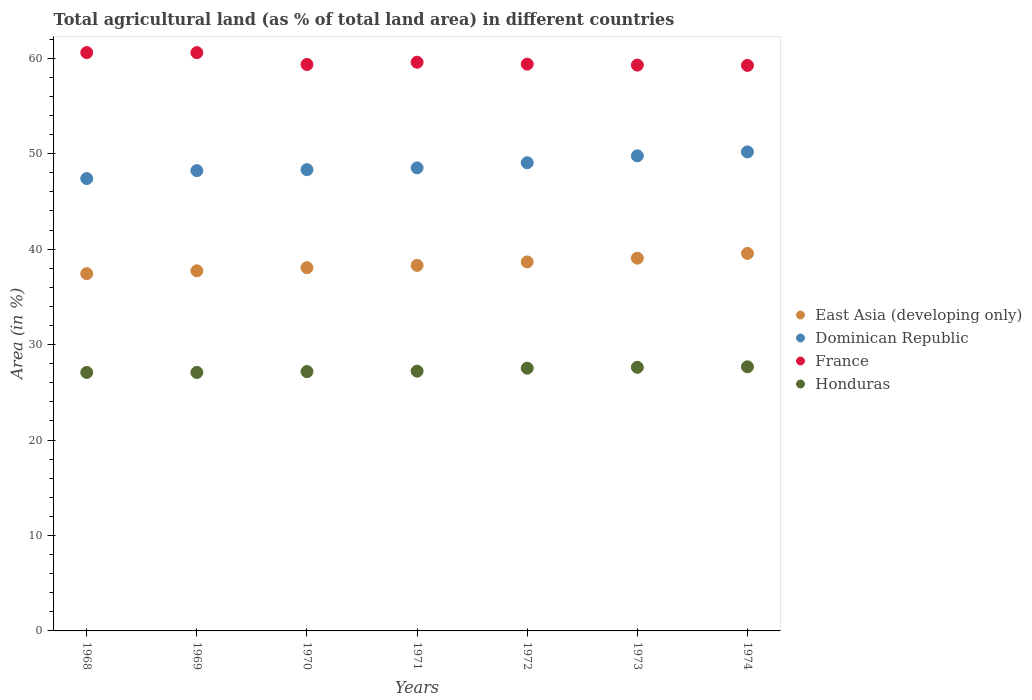How many different coloured dotlines are there?
Keep it short and to the point. 4. What is the percentage of agricultural land in East Asia (developing only) in 1970?
Your answer should be very brief. 38.05. Across all years, what is the maximum percentage of agricultural land in France?
Keep it short and to the point. 60.59. Across all years, what is the minimum percentage of agricultural land in France?
Provide a short and direct response. 59.25. In which year was the percentage of agricultural land in Honduras maximum?
Your response must be concise. 1974. In which year was the percentage of agricultural land in Dominican Republic minimum?
Keep it short and to the point. 1968. What is the total percentage of agricultural land in East Asia (developing only) in the graph?
Keep it short and to the point. 268.76. What is the difference between the percentage of agricultural land in East Asia (developing only) in 1970 and that in 1971?
Offer a terse response. -0.24. What is the difference between the percentage of agricultural land in France in 1970 and the percentage of agricultural land in Honduras in 1974?
Offer a very short reply. 31.67. What is the average percentage of agricultural land in East Asia (developing only) per year?
Make the answer very short. 38.39. In the year 1970, what is the difference between the percentage of agricultural land in France and percentage of agricultural land in Dominican Republic?
Offer a terse response. 11.02. In how many years, is the percentage of agricultural land in France greater than 6 %?
Keep it short and to the point. 7. What is the ratio of the percentage of agricultural land in France in 1969 to that in 1970?
Make the answer very short. 1.02. What is the difference between the highest and the second highest percentage of agricultural land in France?
Keep it short and to the point. 0.01. What is the difference between the highest and the lowest percentage of agricultural land in France?
Provide a succinct answer. 1.34. Is the percentage of agricultural land in France strictly less than the percentage of agricultural land in Honduras over the years?
Keep it short and to the point. No. How many dotlines are there?
Your answer should be very brief. 4. How many years are there in the graph?
Give a very brief answer. 7. Does the graph contain any zero values?
Make the answer very short. No. Does the graph contain grids?
Your response must be concise. No. Where does the legend appear in the graph?
Offer a very short reply. Center right. How many legend labels are there?
Offer a very short reply. 4. What is the title of the graph?
Offer a very short reply. Total agricultural land (as % of total land area) in different countries. Does "Sint Maarten (Dutch part)" appear as one of the legend labels in the graph?
Give a very brief answer. No. What is the label or title of the X-axis?
Provide a succinct answer. Years. What is the label or title of the Y-axis?
Your answer should be very brief. Area (in %). What is the Area (in %) of East Asia (developing only) in 1968?
Make the answer very short. 37.43. What is the Area (in %) of Dominican Republic in 1968?
Make the answer very short. 47.39. What is the Area (in %) of France in 1968?
Give a very brief answer. 60.59. What is the Area (in %) in Honduras in 1968?
Ensure brevity in your answer.  27.08. What is the Area (in %) in East Asia (developing only) in 1969?
Ensure brevity in your answer.  37.73. What is the Area (in %) in Dominican Republic in 1969?
Give a very brief answer. 48.22. What is the Area (in %) of France in 1969?
Give a very brief answer. 60.58. What is the Area (in %) in Honduras in 1969?
Your response must be concise. 27.08. What is the Area (in %) of East Asia (developing only) in 1970?
Provide a short and direct response. 38.05. What is the Area (in %) in Dominican Republic in 1970?
Your answer should be very brief. 48.32. What is the Area (in %) in France in 1970?
Ensure brevity in your answer.  59.34. What is the Area (in %) in Honduras in 1970?
Your answer should be compact. 27.17. What is the Area (in %) in East Asia (developing only) in 1971?
Offer a very short reply. 38.29. What is the Area (in %) in Dominican Republic in 1971?
Your answer should be compact. 48.51. What is the Area (in %) in France in 1971?
Give a very brief answer. 59.58. What is the Area (in %) of Honduras in 1971?
Your answer should be compact. 27.21. What is the Area (in %) of East Asia (developing only) in 1972?
Provide a short and direct response. 38.66. What is the Area (in %) in Dominican Republic in 1972?
Give a very brief answer. 49.05. What is the Area (in %) of France in 1972?
Keep it short and to the point. 59.38. What is the Area (in %) of Honduras in 1972?
Your response must be concise. 27.53. What is the Area (in %) of East Asia (developing only) in 1973?
Keep it short and to the point. 39.05. What is the Area (in %) in Dominican Republic in 1973?
Provide a succinct answer. 49.77. What is the Area (in %) of France in 1973?
Your answer should be very brief. 59.28. What is the Area (in %) of Honduras in 1973?
Ensure brevity in your answer.  27.62. What is the Area (in %) in East Asia (developing only) in 1974?
Keep it short and to the point. 39.55. What is the Area (in %) in Dominican Republic in 1974?
Keep it short and to the point. 50.19. What is the Area (in %) of France in 1974?
Offer a terse response. 59.25. What is the Area (in %) in Honduras in 1974?
Offer a terse response. 27.67. Across all years, what is the maximum Area (in %) in East Asia (developing only)?
Your answer should be compact. 39.55. Across all years, what is the maximum Area (in %) of Dominican Republic?
Your response must be concise. 50.19. Across all years, what is the maximum Area (in %) in France?
Provide a short and direct response. 60.59. Across all years, what is the maximum Area (in %) in Honduras?
Ensure brevity in your answer.  27.67. Across all years, what is the minimum Area (in %) in East Asia (developing only)?
Your response must be concise. 37.43. Across all years, what is the minimum Area (in %) of Dominican Republic?
Offer a terse response. 47.39. Across all years, what is the minimum Area (in %) of France?
Offer a very short reply. 59.25. Across all years, what is the minimum Area (in %) of Honduras?
Make the answer very short. 27.08. What is the total Area (in %) in East Asia (developing only) in the graph?
Your answer should be very brief. 268.76. What is the total Area (in %) of Dominican Republic in the graph?
Ensure brevity in your answer.  341.45. What is the total Area (in %) of France in the graph?
Offer a very short reply. 418.01. What is the total Area (in %) of Honduras in the graph?
Provide a short and direct response. 191.36. What is the difference between the Area (in %) in East Asia (developing only) in 1968 and that in 1969?
Offer a very short reply. -0.3. What is the difference between the Area (in %) in Dominican Republic in 1968 and that in 1969?
Keep it short and to the point. -0.83. What is the difference between the Area (in %) of France in 1968 and that in 1969?
Offer a very short reply. 0.01. What is the difference between the Area (in %) in Honduras in 1968 and that in 1969?
Ensure brevity in your answer.  0. What is the difference between the Area (in %) of East Asia (developing only) in 1968 and that in 1970?
Offer a very short reply. -0.62. What is the difference between the Area (in %) of Dominican Republic in 1968 and that in 1970?
Offer a very short reply. -0.93. What is the difference between the Area (in %) in France in 1968 and that in 1970?
Give a very brief answer. 1.25. What is the difference between the Area (in %) in Honduras in 1968 and that in 1970?
Your answer should be compact. -0.09. What is the difference between the Area (in %) of East Asia (developing only) in 1968 and that in 1971?
Provide a succinct answer. -0.86. What is the difference between the Area (in %) of Dominican Republic in 1968 and that in 1971?
Ensure brevity in your answer.  -1.12. What is the difference between the Area (in %) in France in 1968 and that in 1971?
Provide a short and direct response. 1.01. What is the difference between the Area (in %) in Honduras in 1968 and that in 1971?
Keep it short and to the point. -0.13. What is the difference between the Area (in %) in East Asia (developing only) in 1968 and that in 1972?
Ensure brevity in your answer.  -1.23. What is the difference between the Area (in %) in Dominican Republic in 1968 and that in 1972?
Make the answer very short. -1.66. What is the difference between the Area (in %) in France in 1968 and that in 1972?
Offer a terse response. 1.21. What is the difference between the Area (in %) of Honduras in 1968 and that in 1972?
Your response must be concise. -0.45. What is the difference between the Area (in %) in East Asia (developing only) in 1968 and that in 1973?
Provide a short and direct response. -1.62. What is the difference between the Area (in %) in Dominican Republic in 1968 and that in 1973?
Make the answer very short. -2.38. What is the difference between the Area (in %) in France in 1968 and that in 1973?
Your answer should be very brief. 1.31. What is the difference between the Area (in %) of Honduras in 1968 and that in 1973?
Keep it short and to the point. -0.54. What is the difference between the Area (in %) of East Asia (developing only) in 1968 and that in 1974?
Provide a short and direct response. -2.12. What is the difference between the Area (in %) in Dominican Republic in 1968 and that in 1974?
Your answer should be very brief. -2.79. What is the difference between the Area (in %) in France in 1968 and that in 1974?
Provide a succinct answer. 1.34. What is the difference between the Area (in %) in Honduras in 1968 and that in 1974?
Provide a succinct answer. -0.59. What is the difference between the Area (in %) of East Asia (developing only) in 1969 and that in 1970?
Keep it short and to the point. -0.32. What is the difference between the Area (in %) in Dominican Republic in 1969 and that in 1970?
Your answer should be compact. -0.1. What is the difference between the Area (in %) in France in 1969 and that in 1970?
Offer a very short reply. 1.24. What is the difference between the Area (in %) in Honduras in 1969 and that in 1970?
Provide a short and direct response. -0.09. What is the difference between the Area (in %) of East Asia (developing only) in 1969 and that in 1971?
Provide a succinct answer. -0.57. What is the difference between the Area (in %) of Dominican Republic in 1969 and that in 1971?
Your answer should be very brief. -0.29. What is the difference between the Area (in %) in Honduras in 1969 and that in 1971?
Your answer should be compact. -0.13. What is the difference between the Area (in %) in East Asia (developing only) in 1969 and that in 1972?
Offer a very short reply. -0.93. What is the difference between the Area (in %) in Dominican Republic in 1969 and that in 1972?
Your answer should be very brief. -0.83. What is the difference between the Area (in %) of France in 1969 and that in 1972?
Keep it short and to the point. 1.2. What is the difference between the Area (in %) of Honduras in 1969 and that in 1972?
Your response must be concise. -0.45. What is the difference between the Area (in %) in East Asia (developing only) in 1969 and that in 1973?
Your answer should be compact. -1.33. What is the difference between the Area (in %) of Dominican Republic in 1969 and that in 1973?
Provide a short and direct response. -1.55. What is the difference between the Area (in %) in France in 1969 and that in 1973?
Provide a short and direct response. 1.3. What is the difference between the Area (in %) in Honduras in 1969 and that in 1973?
Provide a short and direct response. -0.54. What is the difference between the Area (in %) of East Asia (developing only) in 1969 and that in 1974?
Give a very brief answer. -1.82. What is the difference between the Area (in %) in Dominican Republic in 1969 and that in 1974?
Ensure brevity in your answer.  -1.97. What is the difference between the Area (in %) in France in 1969 and that in 1974?
Your answer should be very brief. 1.33. What is the difference between the Area (in %) in Honduras in 1969 and that in 1974?
Your answer should be very brief. -0.59. What is the difference between the Area (in %) of East Asia (developing only) in 1970 and that in 1971?
Make the answer very short. -0.24. What is the difference between the Area (in %) of Dominican Republic in 1970 and that in 1971?
Make the answer very short. -0.19. What is the difference between the Area (in %) in France in 1970 and that in 1971?
Ensure brevity in your answer.  -0.23. What is the difference between the Area (in %) in Honduras in 1970 and that in 1971?
Offer a terse response. -0.04. What is the difference between the Area (in %) of East Asia (developing only) in 1970 and that in 1972?
Your response must be concise. -0.61. What is the difference between the Area (in %) of Dominican Republic in 1970 and that in 1972?
Provide a short and direct response. -0.72. What is the difference between the Area (in %) in France in 1970 and that in 1972?
Give a very brief answer. -0.04. What is the difference between the Area (in %) in Honduras in 1970 and that in 1972?
Provide a short and direct response. -0.36. What is the difference between the Area (in %) of East Asia (developing only) in 1970 and that in 1973?
Provide a succinct answer. -1. What is the difference between the Area (in %) in Dominican Republic in 1970 and that in 1973?
Offer a very short reply. -1.45. What is the difference between the Area (in %) of France in 1970 and that in 1973?
Offer a very short reply. 0.06. What is the difference between the Area (in %) in Honduras in 1970 and that in 1973?
Provide a short and direct response. -0.45. What is the difference between the Area (in %) in East Asia (developing only) in 1970 and that in 1974?
Offer a very short reply. -1.5. What is the difference between the Area (in %) of Dominican Republic in 1970 and that in 1974?
Offer a terse response. -1.86. What is the difference between the Area (in %) in France in 1970 and that in 1974?
Provide a succinct answer. 0.1. What is the difference between the Area (in %) of Honduras in 1970 and that in 1974?
Provide a short and direct response. -0.5. What is the difference between the Area (in %) of East Asia (developing only) in 1971 and that in 1972?
Your response must be concise. -0.36. What is the difference between the Area (in %) of Dominican Republic in 1971 and that in 1972?
Your response must be concise. -0.54. What is the difference between the Area (in %) of France in 1971 and that in 1972?
Your answer should be very brief. 0.2. What is the difference between the Area (in %) of Honduras in 1971 and that in 1972?
Ensure brevity in your answer.  -0.31. What is the difference between the Area (in %) in East Asia (developing only) in 1971 and that in 1973?
Give a very brief answer. -0.76. What is the difference between the Area (in %) of Dominican Republic in 1971 and that in 1973?
Ensure brevity in your answer.  -1.26. What is the difference between the Area (in %) of France in 1971 and that in 1973?
Provide a short and direct response. 0.3. What is the difference between the Area (in %) of Honduras in 1971 and that in 1973?
Your answer should be very brief. -0.4. What is the difference between the Area (in %) in East Asia (developing only) in 1971 and that in 1974?
Ensure brevity in your answer.  -1.25. What is the difference between the Area (in %) of Dominican Republic in 1971 and that in 1974?
Keep it short and to the point. -1.68. What is the difference between the Area (in %) in France in 1971 and that in 1974?
Offer a very short reply. 0.33. What is the difference between the Area (in %) in Honduras in 1971 and that in 1974?
Give a very brief answer. -0.46. What is the difference between the Area (in %) of East Asia (developing only) in 1972 and that in 1973?
Make the answer very short. -0.4. What is the difference between the Area (in %) in Dominican Republic in 1972 and that in 1973?
Keep it short and to the point. -0.72. What is the difference between the Area (in %) of France in 1972 and that in 1973?
Your answer should be compact. 0.1. What is the difference between the Area (in %) in Honduras in 1972 and that in 1973?
Make the answer very short. -0.09. What is the difference between the Area (in %) in East Asia (developing only) in 1972 and that in 1974?
Offer a terse response. -0.89. What is the difference between the Area (in %) of Dominican Republic in 1972 and that in 1974?
Make the answer very short. -1.14. What is the difference between the Area (in %) in France in 1972 and that in 1974?
Make the answer very short. 0.13. What is the difference between the Area (in %) of Honduras in 1972 and that in 1974?
Your answer should be very brief. -0.14. What is the difference between the Area (in %) in East Asia (developing only) in 1973 and that in 1974?
Provide a short and direct response. -0.49. What is the difference between the Area (in %) of Dominican Republic in 1973 and that in 1974?
Your answer should be very brief. -0.41. What is the difference between the Area (in %) of France in 1973 and that in 1974?
Provide a succinct answer. 0.03. What is the difference between the Area (in %) of Honduras in 1973 and that in 1974?
Keep it short and to the point. -0.05. What is the difference between the Area (in %) of East Asia (developing only) in 1968 and the Area (in %) of Dominican Republic in 1969?
Your answer should be compact. -10.79. What is the difference between the Area (in %) in East Asia (developing only) in 1968 and the Area (in %) in France in 1969?
Provide a short and direct response. -23.15. What is the difference between the Area (in %) of East Asia (developing only) in 1968 and the Area (in %) of Honduras in 1969?
Your answer should be very brief. 10.35. What is the difference between the Area (in %) in Dominican Republic in 1968 and the Area (in %) in France in 1969?
Your answer should be compact. -13.19. What is the difference between the Area (in %) of Dominican Republic in 1968 and the Area (in %) of Honduras in 1969?
Your response must be concise. 20.31. What is the difference between the Area (in %) in France in 1968 and the Area (in %) in Honduras in 1969?
Keep it short and to the point. 33.51. What is the difference between the Area (in %) in East Asia (developing only) in 1968 and the Area (in %) in Dominican Republic in 1970?
Your answer should be very brief. -10.89. What is the difference between the Area (in %) of East Asia (developing only) in 1968 and the Area (in %) of France in 1970?
Offer a very short reply. -21.91. What is the difference between the Area (in %) of East Asia (developing only) in 1968 and the Area (in %) of Honduras in 1970?
Ensure brevity in your answer.  10.26. What is the difference between the Area (in %) of Dominican Republic in 1968 and the Area (in %) of France in 1970?
Give a very brief answer. -11.95. What is the difference between the Area (in %) in Dominican Republic in 1968 and the Area (in %) in Honduras in 1970?
Keep it short and to the point. 20.22. What is the difference between the Area (in %) in France in 1968 and the Area (in %) in Honduras in 1970?
Offer a very short reply. 33.42. What is the difference between the Area (in %) of East Asia (developing only) in 1968 and the Area (in %) of Dominican Republic in 1971?
Your answer should be very brief. -11.08. What is the difference between the Area (in %) in East Asia (developing only) in 1968 and the Area (in %) in France in 1971?
Provide a short and direct response. -22.15. What is the difference between the Area (in %) of East Asia (developing only) in 1968 and the Area (in %) of Honduras in 1971?
Your response must be concise. 10.22. What is the difference between the Area (in %) of Dominican Republic in 1968 and the Area (in %) of France in 1971?
Your answer should be compact. -12.19. What is the difference between the Area (in %) of Dominican Republic in 1968 and the Area (in %) of Honduras in 1971?
Provide a short and direct response. 20.18. What is the difference between the Area (in %) of France in 1968 and the Area (in %) of Honduras in 1971?
Provide a short and direct response. 33.38. What is the difference between the Area (in %) of East Asia (developing only) in 1968 and the Area (in %) of Dominican Republic in 1972?
Keep it short and to the point. -11.62. What is the difference between the Area (in %) of East Asia (developing only) in 1968 and the Area (in %) of France in 1972?
Ensure brevity in your answer.  -21.95. What is the difference between the Area (in %) of East Asia (developing only) in 1968 and the Area (in %) of Honduras in 1972?
Make the answer very short. 9.9. What is the difference between the Area (in %) in Dominican Republic in 1968 and the Area (in %) in France in 1972?
Offer a terse response. -11.99. What is the difference between the Area (in %) of Dominican Republic in 1968 and the Area (in %) of Honduras in 1972?
Offer a very short reply. 19.87. What is the difference between the Area (in %) of France in 1968 and the Area (in %) of Honduras in 1972?
Give a very brief answer. 33.06. What is the difference between the Area (in %) in East Asia (developing only) in 1968 and the Area (in %) in Dominican Republic in 1973?
Give a very brief answer. -12.34. What is the difference between the Area (in %) of East Asia (developing only) in 1968 and the Area (in %) of France in 1973?
Keep it short and to the point. -21.85. What is the difference between the Area (in %) of East Asia (developing only) in 1968 and the Area (in %) of Honduras in 1973?
Make the answer very short. 9.81. What is the difference between the Area (in %) of Dominican Republic in 1968 and the Area (in %) of France in 1973?
Keep it short and to the point. -11.89. What is the difference between the Area (in %) in Dominican Republic in 1968 and the Area (in %) in Honduras in 1973?
Your answer should be compact. 19.78. What is the difference between the Area (in %) of France in 1968 and the Area (in %) of Honduras in 1973?
Your response must be concise. 32.98. What is the difference between the Area (in %) in East Asia (developing only) in 1968 and the Area (in %) in Dominican Republic in 1974?
Your response must be concise. -12.76. What is the difference between the Area (in %) in East Asia (developing only) in 1968 and the Area (in %) in France in 1974?
Offer a terse response. -21.82. What is the difference between the Area (in %) of East Asia (developing only) in 1968 and the Area (in %) of Honduras in 1974?
Offer a terse response. 9.76. What is the difference between the Area (in %) of Dominican Republic in 1968 and the Area (in %) of France in 1974?
Provide a short and direct response. -11.86. What is the difference between the Area (in %) of Dominican Republic in 1968 and the Area (in %) of Honduras in 1974?
Your answer should be very brief. 19.72. What is the difference between the Area (in %) of France in 1968 and the Area (in %) of Honduras in 1974?
Your answer should be very brief. 32.92. What is the difference between the Area (in %) in East Asia (developing only) in 1969 and the Area (in %) in Dominican Republic in 1970?
Your answer should be compact. -10.6. What is the difference between the Area (in %) of East Asia (developing only) in 1969 and the Area (in %) of France in 1970?
Keep it short and to the point. -21.62. What is the difference between the Area (in %) of East Asia (developing only) in 1969 and the Area (in %) of Honduras in 1970?
Your response must be concise. 10.56. What is the difference between the Area (in %) of Dominican Republic in 1969 and the Area (in %) of France in 1970?
Make the answer very short. -11.12. What is the difference between the Area (in %) of Dominican Republic in 1969 and the Area (in %) of Honduras in 1970?
Provide a short and direct response. 21.05. What is the difference between the Area (in %) of France in 1969 and the Area (in %) of Honduras in 1970?
Make the answer very short. 33.41. What is the difference between the Area (in %) of East Asia (developing only) in 1969 and the Area (in %) of Dominican Republic in 1971?
Provide a short and direct response. -10.78. What is the difference between the Area (in %) in East Asia (developing only) in 1969 and the Area (in %) in France in 1971?
Keep it short and to the point. -21.85. What is the difference between the Area (in %) of East Asia (developing only) in 1969 and the Area (in %) of Honduras in 1971?
Your answer should be very brief. 10.51. What is the difference between the Area (in %) in Dominican Republic in 1969 and the Area (in %) in France in 1971?
Give a very brief answer. -11.36. What is the difference between the Area (in %) in Dominican Republic in 1969 and the Area (in %) in Honduras in 1971?
Offer a very short reply. 21.01. What is the difference between the Area (in %) of France in 1969 and the Area (in %) of Honduras in 1971?
Offer a very short reply. 33.37. What is the difference between the Area (in %) of East Asia (developing only) in 1969 and the Area (in %) of Dominican Republic in 1972?
Keep it short and to the point. -11.32. What is the difference between the Area (in %) of East Asia (developing only) in 1969 and the Area (in %) of France in 1972?
Offer a terse response. -21.65. What is the difference between the Area (in %) in East Asia (developing only) in 1969 and the Area (in %) in Honduras in 1972?
Offer a terse response. 10.2. What is the difference between the Area (in %) of Dominican Republic in 1969 and the Area (in %) of France in 1972?
Ensure brevity in your answer.  -11.16. What is the difference between the Area (in %) in Dominican Republic in 1969 and the Area (in %) in Honduras in 1972?
Provide a short and direct response. 20.69. What is the difference between the Area (in %) of France in 1969 and the Area (in %) of Honduras in 1972?
Keep it short and to the point. 33.06. What is the difference between the Area (in %) in East Asia (developing only) in 1969 and the Area (in %) in Dominican Republic in 1973?
Your answer should be very brief. -12.04. What is the difference between the Area (in %) in East Asia (developing only) in 1969 and the Area (in %) in France in 1973?
Your response must be concise. -21.55. What is the difference between the Area (in %) of East Asia (developing only) in 1969 and the Area (in %) of Honduras in 1973?
Offer a very short reply. 10.11. What is the difference between the Area (in %) in Dominican Republic in 1969 and the Area (in %) in France in 1973?
Make the answer very short. -11.06. What is the difference between the Area (in %) of Dominican Republic in 1969 and the Area (in %) of Honduras in 1973?
Your response must be concise. 20.6. What is the difference between the Area (in %) in France in 1969 and the Area (in %) in Honduras in 1973?
Offer a very short reply. 32.97. What is the difference between the Area (in %) of East Asia (developing only) in 1969 and the Area (in %) of Dominican Republic in 1974?
Offer a terse response. -12.46. What is the difference between the Area (in %) in East Asia (developing only) in 1969 and the Area (in %) in France in 1974?
Your answer should be compact. -21.52. What is the difference between the Area (in %) in East Asia (developing only) in 1969 and the Area (in %) in Honduras in 1974?
Give a very brief answer. 10.06. What is the difference between the Area (in %) in Dominican Republic in 1969 and the Area (in %) in France in 1974?
Offer a terse response. -11.03. What is the difference between the Area (in %) in Dominican Republic in 1969 and the Area (in %) in Honduras in 1974?
Offer a terse response. 20.55. What is the difference between the Area (in %) in France in 1969 and the Area (in %) in Honduras in 1974?
Keep it short and to the point. 32.91. What is the difference between the Area (in %) of East Asia (developing only) in 1970 and the Area (in %) of Dominican Republic in 1971?
Give a very brief answer. -10.46. What is the difference between the Area (in %) of East Asia (developing only) in 1970 and the Area (in %) of France in 1971?
Ensure brevity in your answer.  -21.53. What is the difference between the Area (in %) in East Asia (developing only) in 1970 and the Area (in %) in Honduras in 1971?
Ensure brevity in your answer.  10.84. What is the difference between the Area (in %) of Dominican Republic in 1970 and the Area (in %) of France in 1971?
Make the answer very short. -11.25. What is the difference between the Area (in %) in Dominican Republic in 1970 and the Area (in %) in Honduras in 1971?
Your answer should be compact. 21.11. What is the difference between the Area (in %) in France in 1970 and the Area (in %) in Honduras in 1971?
Provide a short and direct response. 32.13. What is the difference between the Area (in %) in East Asia (developing only) in 1970 and the Area (in %) in Dominican Republic in 1972?
Provide a succinct answer. -11. What is the difference between the Area (in %) of East Asia (developing only) in 1970 and the Area (in %) of France in 1972?
Provide a succinct answer. -21.33. What is the difference between the Area (in %) of East Asia (developing only) in 1970 and the Area (in %) of Honduras in 1972?
Give a very brief answer. 10.52. What is the difference between the Area (in %) of Dominican Republic in 1970 and the Area (in %) of France in 1972?
Keep it short and to the point. -11.06. What is the difference between the Area (in %) in Dominican Republic in 1970 and the Area (in %) in Honduras in 1972?
Provide a succinct answer. 20.8. What is the difference between the Area (in %) in France in 1970 and the Area (in %) in Honduras in 1972?
Offer a very short reply. 31.82. What is the difference between the Area (in %) of East Asia (developing only) in 1970 and the Area (in %) of Dominican Republic in 1973?
Your answer should be very brief. -11.72. What is the difference between the Area (in %) of East Asia (developing only) in 1970 and the Area (in %) of France in 1973?
Offer a terse response. -21.23. What is the difference between the Area (in %) in East Asia (developing only) in 1970 and the Area (in %) in Honduras in 1973?
Offer a very short reply. 10.44. What is the difference between the Area (in %) of Dominican Republic in 1970 and the Area (in %) of France in 1973?
Provide a succinct answer. -10.96. What is the difference between the Area (in %) in Dominican Republic in 1970 and the Area (in %) in Honduras in 1973?
Your answer should be compact. 20.71. What is the difference between the Area (in %) in France in 1970 and the Area (in %) in Honduras in 1973?
Your response must be concise. 31.73. What is the difference between the Area (in %) in East Asia (developing only) in 1970 and the Area (in %) in Dominican Republic in 1974?
Offer a very short reply. -12.13. What is the difference between the Area (in %) of East Asia (developing only) in 1970 and the Area (in %) of France in 1974?
Ensure brevity in your answer.  -21.2. What is the difference between the Area (in %) of East Asia (developing only) in 1970 and the Area (in %) of Honduras in 1974?
Provide a succinct answer. 10.38. What is the difference between the Area (in %) of Dominican Republic in 1970 and the Area (in %) of France in 1974?
Your answer should be very brief. -10.92. What is the difference between the Area (in %) of Dominican Republic in 1970 and the Area (in %) of Honduras in 1974?
Give a very brief answer. 20.65. What is the difference between the Area (in %) in France in 1970 and the Area (in %) in Honduras in 1974?
Make the answer very short. 31.67. What is the difference between the Area (in %) in East Asia (developing only) in 1971 and the Area (in %) in Dominican Republic in 1972?
Provide a succinct answer. -10.75. What is the difference between the Area (in %) in East Asia (developing only) in 1971 and the Area (in %) in France in 1972?
Offer a very short reply. -21.09. What is the difference between the Area (in %) in East Asia (developing only) in 1971 and the Area (in %) in Honduras in 1972?
Ensure brevity in your answer.  10.77. What is the difference between the Area (in %) in Dominican Republic in 1971 and the Area (in %) in France in 1972?
Offer a terse response. -10.87. What is the difference between the Area (in %) of Dominican Republic in 1971 and the Area (in %) of Honduras in 1972?
Ensure brevity in your answer.  20.98. What is the difference between the Area (in %) of France in 1971 and the Area (in %) of Honduras in 1972?
Give a very brief answer. 32.05. What is the difference between the Area (in %) of East Asia (developing only) in 1971 and the Area (in %) of Dominican Republic in 1973?
Make the answer very short. -11.48. What is the difference between the Area (in %) of East Asia (developing only) in 1971 and the Area (in %) of France in 1973?
Keep it short and to the point. -20.99. What is the difference between the Area (in %) of East Asia (developing only) in 1971 and the Area (in %) of Honduras in 1973?
Provide a short and direct response. 10.68. What is the difference between the Area (in %) of Dominican Republic in 1971 and the Area (in %) of France in 1973?
Provide a succinct answer. -10.77. What is the difference between the Area (in %) of Dominican Republic in 1971 and the Area (in %) of Honduras in 1973?
Ensure brevity in your answer.  20.89. What is the difference between the Area (in %) of France in 1971 and the Area (in %) of Honduras in 1973?
Ensure brevity in your answer.  31.96. What is the difference between the Area (in %) of East Asia (developing only) in 1971 and the Area (in %) of Dominican Republic in 1974?
Offer a very short reply. -11.89. What is the difference between the Area (in %) of East Asia (developing only) in 1971 and the Area (in %) of France in 1974?
Your answer should be very brief. -20.95. What is the difference between the Area (in %) in East Asia (developing only) in 1971 and the Area (in %) in Honduras in 1974?
Ensure brevity in your answer.  10.62. What is the difference between the Area (in %) in Dominican Republic in 1971 and the Area (in %) in France in 1974?
Your response must be concise. -10.74. What is the difference between the Area (in %) of Dominican Republic in 1971 and the Area (in %) of Honduras in 1974?
Your answer should be very brief. 20.84. What is the difference between the Area (in %) of France in 1971 and the Area (in %) of Honduras in 1974?
Make the answer very short. 31.91. What is the difference between the Area (in %) of East Asia (developing only) in 1972 and the Area (in %) of Dominican Republic in 1973?
Keep it short and to the point. -11.11. What is the difference between the Area (in %) in East Asia (developing only) in 1972 and the Area (in %) in France in 1973?
Your answer should be compact. -20.62. What is the difference between the Area (in %) of East Asia (developing only) in 1972 and the Area (in %) of Honduras in 1973?
Your answer should be very brief. 11.04. What is the difference between the Area (in %) in Dominican Republic in 1972 and the Area (in %) in France in 1973?
Your answer should be compact. -10.23. What is the difference between the Area (in %) in Dominican Republic in 1972 and the Area (in %) in Honduras in 1973?
Give a very brief answer. 21.43. What is the difference between the Area (in %) of France in 1972 and the Area (in %) of Honduras in 1973?
Make the answer very short. 31.76. What is the difference between the Area (in %) of East Asia (developing only) in 1972 and the Area (in %) of Dominican Republic in 1974?
Offer a very short reply. -11.53. What is the difference between the Area (in %) of East Asia (developing only) in 1972 and the Area (in %) of France in 1974?
Offer a terse response. -20.59. What is the difference between the Area (in %) in East Asia (developing only) in 1972 and the Area (in %) in Honduras in 1974?
Your response must be concise. 10.99. What is the difference between the Area (in %) in Dominican Republic in 1972 and the Area (in %) in France in 1974?
Provide a succinct answer. -10.2. What is the difference between the Area (in %) of Dominican Republic in 1972 and the Area (in %) of Honduras in 1974?
Make the answer very short. 21.38. What is the difference between the Area (in %) in France in 1972 and the Area (in %) in Honduras in 1974?
Keep it short and to the point. 31.71. What is the difference between the Area (in %) of East Asia (developing only) in 1973 and the Area (in %) of Dominican Republic in 1974?
Your answer should be compact. -11.13. What is the difference between the Area (in %) in East Asia (developing only) in 1973 and the Area (in %) in France in 1974?
Your answer should be compact. -20.19. What is the difference between the Area (in %) of East Asia (developing only) in 1973 and the Area (in %) of Honduras in 1974?
Your response must be concise. 11.38. What is the difference between the Area (in %) of Dominican Republic in 1973 and the Area (in %) of France in 1974?
Provide a short and direct response. -9.48. What is the difference between the Area (in %) of Dominican Republic in 1973 and the Area (in %) of Honduras in 1974?
Your response must be concise. 22.1. What is the difference between the Area (in %) in France in 1973 and the Area (in %) in Honduras in 1974?
Ensure brevity in your answer.  31.61. What is the average Area (in %) in East Asia (developing only) per year?
Provide a short and direct response. 38.39. What is the average Area (in %) in Dominican Republic per year?
Ensure brevity in your answer.  48.78. What is the average Area (in %) of France per year?
Offer a terse response. 59.72. What is the average Area (in %) in Honduras per year?
Offer a very short reply. 27.34. In the year 1968, what is the difference between the Area (in %) in East Asia (developing only) and Area (in %) in Dominican Republic?
Provide a succinct answer. -9.96. In the year 1968, what is the difference between the Area (in %) in East Asia (developing only) and Area (in %) in France?
Provide a short and direct response. -23.16. In the year 1968, what is the difference between the Area (in %) of East Asia (developing only) and Area (in %) of Honduras?
Your answer should be compact. 10.35. In the year 1968, what is the difference between the Area (in %) in Dominican Republic and Area (in %) in France?
Provide a short and direct response. -13.2. In the year 1968, what is the difference between the Area (in %) in Dominican Republic and Area (in %) in Honduras?
Offer a very short reply. 20.31. In the year 1968, what is the difference between the Area (in %) of France and Area (in %) of Honduras?
Offer a very short reply. 33.51. In the year 1969, what is the difference between the Area (in %) in East Asia (developing only) and Area (in %) in Dominican Republic?
Your response must be concise. -10.49. In the year 1969, what is the difference between the Area (in %) of East Asia (developing only) and Area (in %) of France?
Ensure brevity in your answer.  -22.86. In the year 1969, what is the difference between the Area (in %) in East Asia (developing only) and Area (in %) in Honduras?
Give a very brief answer. 10.65. In the year 1969, what is the difference between the Area (in %) in Dominican Republic and Area (in %) in France?
Provide a short and direct response. -12.36. In the year 1969, what is the difference between the Area (in %) in Dominican Republic and Area (in %) in Honduras?
Ensure brevity in your answer.  21.14. In the year 1969, what is the difference between the Area (in %) of France and Area (in %) of Honduras?
Your response must be concise. 33.5. In the year 1970, what is the difference between the Area (in %) in East Asia (developing only) and Area (in %) in Dominican Republic?
Make the answer very short. -10.27. In the year 1970, what is the difference between the Area (in %) of East Asia (developing only) and Area (in %) of France?
Provide a succinct answer. -21.29. In the year 1970, what is the difference between the Area (in %) of East Asia (developing only) and Area (in %) of Honduras?
Provide a short and direct response. 10.88. In the year 1970, what is the difference between the Area (in %) in Dominican Republic and Area (in %) in France?
Provide a succinct answer. -11.02. In the year 1970, what is the difference between the Area (in %) in Dominican Republic and Area (in %) in Honduras?
Give a very brief answer. 21.15. In the year 1970, what is the difference between the Area (in %) of France and Area (in %) of Honduras?
Provide a short and direct response. 32.17. In the year 1971, what is the difference between the Area (in %) in East Asia (developing only) and Area (in %) in Dominican Republic?
Provide a short and direct response. -10.22. In the year 1971, what is the difference between the Area (in %) of East Asia (developing only) and Area (in %) of France?
Provide a short and direct response. -21.28. In the year 1971, what is the difference between the Area (in %) in East Asia (developing only) and Area (in %) in Honduras?
Offer a very short reply. 11.08. In the year 1971, what is the difference between the Area (in %) in Dominican Republic and Area (in %) in France?
Keep it short and to the point. -11.07. In the year 1971, what is the difference between the Area (in %) in Dominican Republic and Area (in %) in Honduras?
Give a very brief answer. 21.3. In the year 1971, what is the difference between the Area (in %) in France and Area (in %) in Honduras?
Your answer should be very brief. 32.36. In the year 1972, what is the difference between the Area (in %) of East Asia (developing only) and Area (in %) of Dominican Republic?
Your answer should be very brief. -10.39. In the year 1972, what is the difference between the Area (in %) of East Asia (developing only) and Area (in %) of France?
Your response must be concise. -20.72. In the year 1972, what is the difference between the Area (in %) of East Asia (developing only) and Area (in %) of Honduras?
Offer a very short reply. 11.13. In the year 1972, what is the difference between the Area (in %) in Dominican Republic and Area (in %) in France?
Give a very brief answer. -10.33. In the year 1972, what is the difference between the Area (in %) of Dominican Republic and Area (in %) of Honduras?
Your answer should be very brief. 21.52. In the year 1972, what is the difference between the Area (in %) in France and Area (in %) in Honduras?
Provide a short and direct response. 31.85. In the year 1973, what is the difference between the Area (in %) in East Asia (developing only) and Area (in %) in Dominican Republic?
Offer a very short reply. -10.72. In the year 1973, what is the difference between the Area (in %) in East Asia (developing only) and Area (in %) in France?
Give a very brief answer. -20.23. In the year 1973, what is the difference between the Area (in %) in East Asia (developing only) and Area (in %) in Honduras?
Keep it short and to the point. 11.44. In the year 1973, what is the difference between the Area (in %) of Dominican Republic and Area (in %) of France?
Your response must be concise. -9.51. In the year 1973, what is the difference between the Area (in %) of Dominican Republic and Area (in %) of Honduras?
Make the answer very short. 22.16. In the year 1973, what is the difference between the Area (in %) in France and Area (in %) in Honduras?
Provide a succinct answer. 31.66. In the year 1974, what is the difference between the Area (in %) in East Asia (developing only) and Area (in %) in Dominican Republic?
Give a very brief answer. -10.64. In the year 1974, what is the difference between the Area (in %) of East Asia (developing only) and Area (in %) of France?
Keep it short and to the point. -19.7. In the year 1974, what is the difference between the Area (in %) in East Asia (developing only) and Area (in %) in Honduras?
Ensure brevity in your answer.  11.88. In the year 1974, what is the difference between the Area (in %) in Dominican Republic and Area (in %) in France?
Your answer should be compact. -9.06. In the year 1974, what is the difference between the Area (in %) in Dominican Republic and Area (in %) in Honduras?
Your answer should be compact. 22.52. In the year 1974, what is the difference between the Area (in %) in France and Area (in %) in Honduras?
Provide a short and direct response. 31.58. What is the ratio of the Area (in %) in East Asia (developing only) in 1968 to that in 1969?
Your response must be concise. 0.99. What is the ratio of the Area (in %) of Dominican Republic in 1968 to that in 1969?
Provide a short and direct response. 0.98. What is the ratio of the Area (in %) in Honduras in 1968 to that in 1969?
Make the answer very short. 1. What is the ratio of the Area (in %) of East Asia (developing only) in 1968 to that in 1970?
Provide a short and direct response. 0.98. What is the ratio of the Area (in %) in Dominican Republic in 1968 to that in 1970?
Give a very brief answer. 0.98. What is the ratio of the Area (in %) of East Asia (developing only) in 1968 to that in 1971?
Your answer should be compact. 0.98. What is the ratio of the Area (in %) in France in 1968 to that in 1971?
Make the answer very short. 1.02. What is the ratio of the Area (in %) of East Asia (developing only) in 1968 to that in 1972?
Provide a succinct answer. 0.97. What is the ratio of the Area (in %) of Dominican Republic in 1968 to that in 1972?
Keep it short and to the point. 0.97. What is the ratio of the Area (in %) in France in 1968 to that in 1972?
Provide a short and direct response. 1.02. What is the ratio of the Area (in %) in Honduras in 1968 to that in 1972?
Your response must be concise. 0.98. What is the ratio of the Area (in %) in East Asia (developing only) in 1968 to that in 1973?
Give a very brief answer. 0.96. What is the ratio of the Area (in %) in Dominican Republic in 1968 to that in 1973?
Your response must be concise. 0.95. What is the ratio of the Area (in %) in France in 1968 to that in 1973?
Offer a very short reply. 1.02. What is the ratio of the Area (in %) in Honduras in 1968 to that in 1973?
Your answer should be compact. 0.98. What is the ratio of the Area (in %) of East Asia (developing only) in 1968 to that in 1974?
Your answer should be very brief. 0.95. What is the ratio of the Area (in %) in Dominican Republic in 1968 to that in 1974?
Provide a succinct answer. 0.94. What is the ratio of the Area (in %) in France in 1968 to that in 1974?
Your answer should be very brief. 1.02. What is the ratio of the Area (in %) in Honduras in 1968 to that in 1974?
Offer a very short reply. 0.98. What is the ratio of the Area (in %) of East Asia (developing only) in 1969 to that in 1970?
Make the answer very short. 0.99. What is the ratio of the Area (in %) in Dominican Republic in 1969 to that in 1970?
Offer a very short reply. 1. What is the ratio of the Area (in %) of France in 1969 to that in 1970?
Offer a very short reply. 1.02. What is the ratio of the Area (in %) in Honduras in 1969 to that in 1970?
Keep it short and to the point. 1. What is the ratio of the Area (in %) of East Asia (developing only) in 1969 to that in 1971?
Offer a terse response. 0.99. What is the ratio of the Area (in %) in France in 1969 to that in 1971?
Your answer should be compact. 1.02. What is the ratio of the Area (in %) in Honduras in 1969 to that in 1971?
Give a very brief answer. 1. What is the ratio of the Area (in %) in East Asia (developing only) in 1969 to that in 1972?
Make the answer very short. 0.98. What is the ratio of the Area (in %) in Dominican Republic in 1969 to that in 1972?
Ensure brevity in your answer.  0.98. What is the ratio of the Area (in %) of France in 1969 to that in 1972?
Keep it short and to the point. 1.02. What is the ratio of the Area (in %) in Honduras in 1969 to that in 1972?
Ensure brevity in your answer.  0.98. What is the ratio of the Area (in %) in East Asia (developing only) in 1969 to that in 1973?
Offer a very short reply. 0.97. What is the ratio of the Area (in %) in Dominican Republic in 1969 to that in 1973?
Make the answer very short. 0.97. What is the ratio of the Area (in %) in Honduras in 1969 to that in 1973?
Your answer should be very brief. 0.98. What is the ratio of the Area (in %) in East Asia (developing only) in 1969 to that in 1974?
Your response must be concise. 0.95. What is the ratio of the Area (in %) in Dominican Republic in 1969 to that in 1974?
Your answer should be very brief. 0.96. What is the ratio of the Area (in %) in France in 1969 to that in 1974?
Ensure brevity in your answer.  1.02. What is the ratio of the Area (in %) in Honduras in 1969 to that in 1974?
Give a very brief answer. 0.98. What is the ratio of the Area (in %) of East Asia (developing only) in 1970 to that in 1971?
Provide a short and direct response. 0.99. What is the ratio of the Area (in %) in France in 1970 to that in 1971?
Your answer should be very brief. 1. What is the ratio of the Area (in %) in Honduras in 1970 to that in 1971?
Offer a terse response. 1. What is the ratio of the Area (in %) in East Asia (developing only) in 1970 to that in 1972?
Keep it short and to the point. 0.98. What is the ratio of the Area (in %) of Dominican Republic in 1970 to that in 1972?
Make the answer very short. 0.99. What is the ratio of the Area (in %) in France in 1970 to that in 1972?
Your response must be concise. 1. What is the ratio of the Area (in %) of Honduras in 1970 to that in 1972?
Ensure brevity in your answer.  0.99. What is the ratio of the Area (in %) in East Asia (developing only) in 1970 to that in 1973?
Make the answer very short. 0.97. What is the ratio of the Area (in %) of Dominican Republic in 1970 to that in 1973?
Provide a succinct answer. 0.97. What is the ratio of the Area (in %) in Honduras in 1970 to that in 1973?
Offer a terse response. 0.98. What is the ratio of the Area (in %) of East Asia (developing only) in 1970 to that in 1974?
Provide a short and direct response. 0.96. What is the ratio of the Area (in %) in Dominican Republic in 1970 to that in 1974?
Provide a succinct answer. 0.96. What is the ratio of the Area (in %) in Honduras in 1970 to that in 1974?
Your response must be concise. 0.98. What is the ratio of the Area (in %) in East Asia (developing only) in 1971 to that in 1972?
Your response must be concise. 0.99. What is the ratio of the Area (in %) of France in 1971 to that in 1972?
Ensure brevity in your answer.  1. What is the ratio of the Area (in %) of Honduras in 1971 to that in 1972?
Your answer should be very brief. 0.99. What is the ratio of the Area (in %) of East Asia (developing only) in 1971 to that in 1973?
Provide a succinct answer. 0.98. What is the ratio of the Area (in %) in Dominican Republic in 1971 to that in 1973?
Your answer should be very brief. 0.97. What is the ratio of the Area (in %) in France in 1971 to that in 1973?
Keep it short and to the point. 1. What is the ratio of the Area (in %) of Honduras in 1971 to that in 1973?
Provide a short and direct response. 0.99. What is the ratio of the Area (in %) in East Asia (developing only) in 1971 to that in 1974?
Your response must be concise. 0.97. What is the ratio of the Area (in %) in Dominican Republic in 1971 to that in 1974?
Keep it short and to the point. 0.97. What is the ratio of the Area (in %) in France in 1971 to that in 1974?
Make the answer very short. 1.01. What is the ratio of the Area (in %) of Honduras in 1971 to that in 1974?
Your response must be concise. 0.98. What is the ratio of the Area (in %) in Dominican Republic in 1972 to that in 1973?
Make the answer very short. 0.99. What is the ratio of the Area (in %) in France in 1972 to that in 1973?
Provide a short and direct response. 1. What is the ratio of the Area (in %) of East Asia (developing only) in 1972 to that in 1974?
Offer a very short reply. 0.98. What is the ratio of the Area (in %) of Dominican Republic in 1972 to that in 1974?
Your answer should be very brief. 0.98. What is the ratio of the Area (in %) of France in 1972 to that in 1974?
Make the answer very short. 1. What is the ratio of the Area (in %) of Honduras in 1972 to that in 1974?
Provide a succinct answer. 0.99. What is the ratio of the Area (in %) in East Asia (developing only) in 1973 to that in 1974?
Your answer should be compact. 0.99. What is the ratio of the Area (in %) in Dominican Republic in 1973 to that in 1974?
Provide a short and direct response. 0.99. What is the ratio of the Area (in %) of France in 1973 to that in 1974?
Provide a short and direct response. 1. What is the difference between the highest and the second highest Area (in %) of East Asia (developing only)?
Offer a terse response. 0.49. What is the difference between the highest and the second highest Area (in %) in Dominican Republic?
Ensure brevity in your answer.  0.41. What is the difference between the highest and the second highest Area (in %) in France?
Make the answer very short. 0.01. What is the difference between the highest and the second highest Area (in %) of Honduras?
Your answer should be compact. 0.05. What is the difference between the highest and the lowest Area (in %) in East Asia (developing only)?
Provide a succinct answer. 2.12. What is the difference between the highest and the lowest Area (in %) of Dominican Republic?
Your response must be concise. 2.79. What is the difference between the highest and the lowest Area (in %) in France?
Provide a short and direct response. 1.34. What is the difference between the highest and the lowest Area (in %) of Honduras?
Make the answer very short. 0.59. 